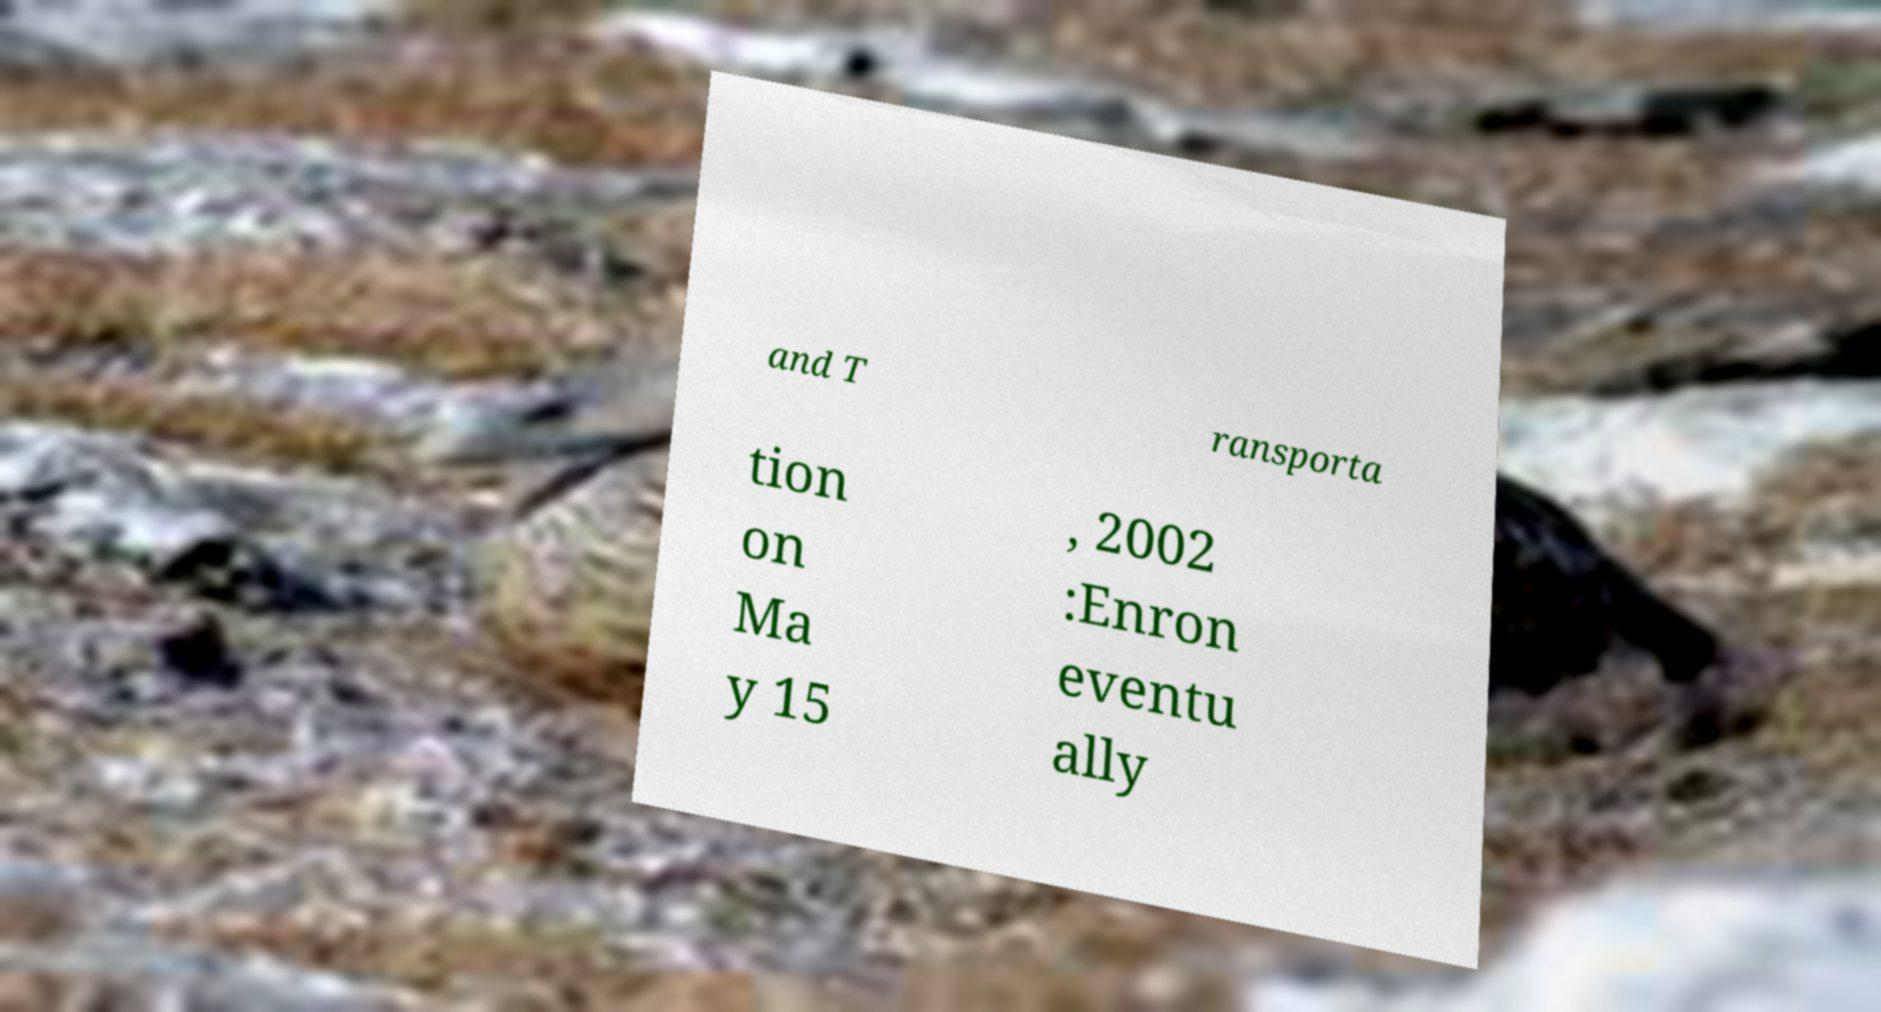Please identify and transcribe the text found in this image. and T ransporta tion on Ma y 15 , 2002 :Enron eventu ally 